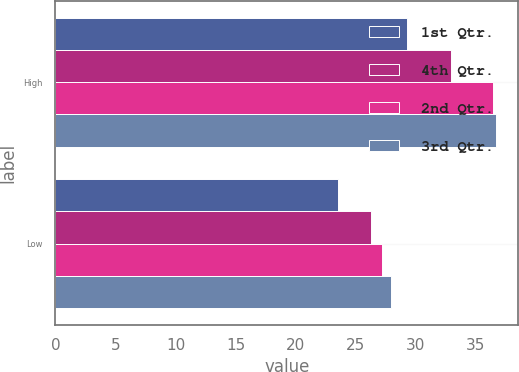Convert chart. <chart><loc_0><loc_0><loc_500><loc_500><stacked_bar_chart><ecel><fcel>High<fcel>Low<nl><fcel>1st Qtr.<fcel>29.33<fcel>23.55<nl><fcel>4th Qtr.<fcel>32.94<fcel>26.26<nl><fcel>2nd Qtr.<fcel>36.48<fcel>27.24<nl><fcel>3rd Qtr.<fcel>36.72<fcel>27.96<nl></chart> 